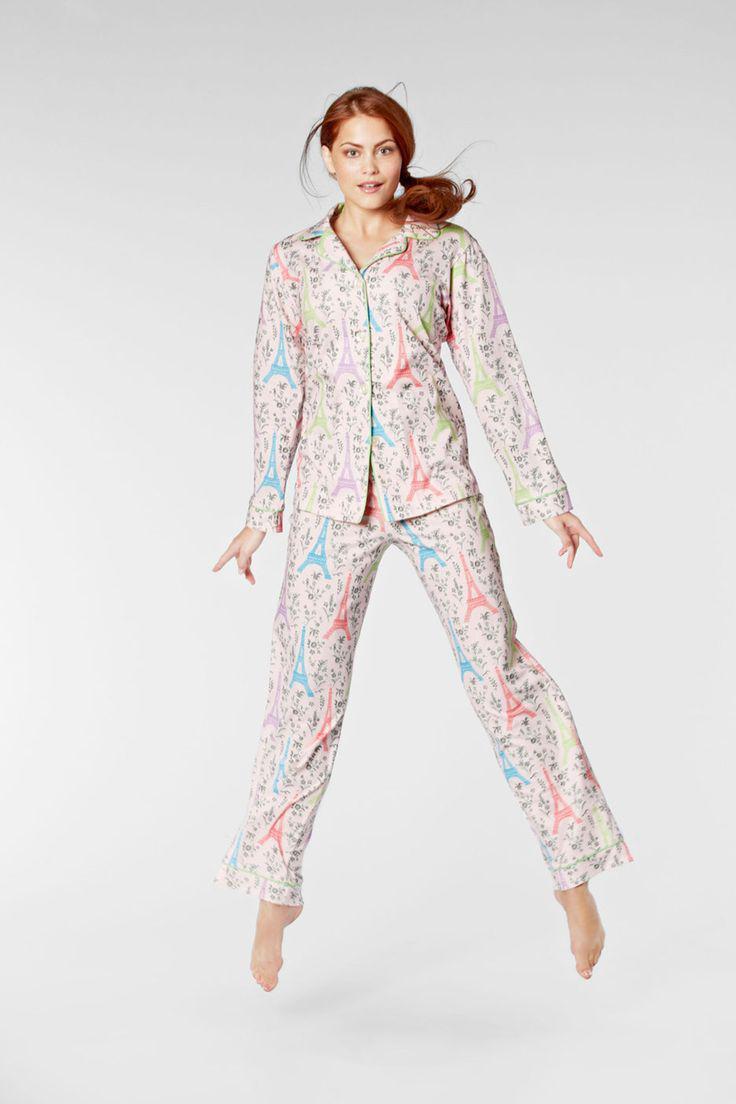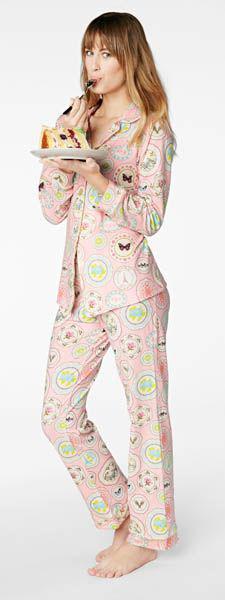The first image is the image on the left, the second image is the image on the right. Evaluate the accuracy of this statement regarding the images: "The woman in the image on the left has her feet close together.". Is it true? Answer yes or no. No. The first image is the image on the left, the second image is the image on the right. For the images shown, is this caption "An adult woman in one image is wearing a printed pajama set with tight fitting pants that have wide, solid-color cuffs at the ankles." true? Answer yes or no. No. 